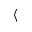Convert formula to latex. <formula><loc_0><loc_0><loc_500><loc_500>\langle</formula> 